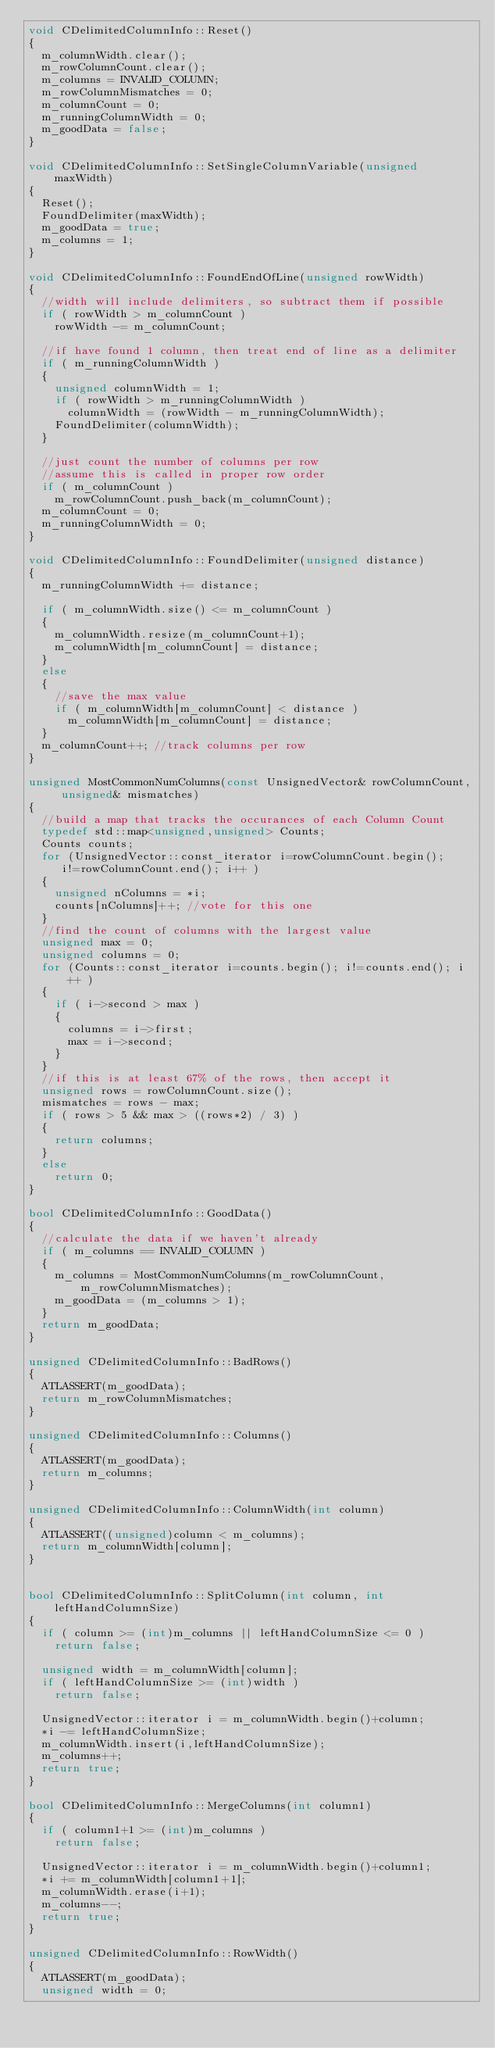Convert code to text. <code><loc_0><loc_0><loc_500><loc_500><_C++_>void CDelimitedColumnInfo::Reset()
{
	m_columnWidth.clear();
	m_rowColumnCount.clear();
	m_columns = INVALID_COLUMN;
	m_rowColumnMismatches = 0;
	m_columnCount = 0;
	m_runningColumnWidth = 0;
	m_goodData = false;
}

void CDelimitedColumnInfo::SetSingleColumnVariable(unsigned maxWidth)
{
	Reset();
	FoundDelimiter(maxWidth);
	m_goodData = true;
	m_columns = 1;
}

void CDelimitedColumnInfo::FoundEndOfLine(unsigned rowWidth)
{
	//width will include delimiters, so subtract them if possible
	if ( rowWidth > m_columnCount )
		rowWidth -= m_columnCount;

	//if have found 1 column, then treat end of line as a delimiter
	if ( m_runningColumnWidth )
	{
		unsigned columnWidth = 1;
		if ( rowWidth > m_runningColumnWidth )
			columnWidth = (rowWidth - m_runningColumnWidth);
		FoundDelimiter(columnWidth);
	}

	//just count the number of columns per row
	//assume this is called in proper row order
	if ( m_columnCount )
		m_rowColumnCount.push_back(m_columnCount);
	m_columnCount = 0;
	m_runningColumnWidth = 0;
}

void CDelimitedColumnInfo::FoundDelimiter(unsigned distance)
{
	m_runningColumnWidth += distance;

	if ( m_columnWidth.size() <= m_columnCount )
	{
		m_columnWidth.resize(m_columnCount+1);
		m_columnWidth[m_columnCount] = distance;
	}
	else
	{
		//save the max value
		if ( m_columnWidth[m_columnCount] < distance )
			m_columnWidth[m_columnCount] = distance;
	}
	m_columnCount++; //track columns per row
}

unsigned MostCommonNumColumns(const UnsignedVector& rowColumnCount, unsigned& mismatches)
{
	//build a map that tracks the occurances of each Column Count
	typedef std::map<unsigned,unsigned> Counts;
	Counts counts;
	for (UnsignedVector::const_iterator i=rowColumnCount.begin();
		 i!=rowColumnCount.end(); i++ )
	{
		unsigned nColumns = *i;
		counts[nColumns]++; //vote for this one
	}
	//find the count of columns with the largest value
	unsigned max = 0;
	unsigned columns = 0;
	for (Counts::const_iterator i=counts.begin(); i!=counts.end(); i++ )
	{
		if ( i->second > max )
		{
			columns = i->first;
			max = i->second;
		}
	}
	//if this is at least 67% of the rows, then accept it
	unsigned rows = rowColumnCount.size();
	mismatches = rows - max;
	if ( rows > 5 && max > ((rows*2) / 3) )
	{
		return columns;
	}
	else
		return 0;
}

bool CDelimitedColumnInfo::GoodData()
{
	//calculate the data if we haven't already
	if ( m_columns == INVALID_COLUMN )
	{
		m_columns = MostCommonNumColumns(m_rowColumnCount,m_rowColumnMismatches);
		m_goodData = (m_columns > 1);
	}
	return m_goodData;
}

unsigned CDelimitedColumnInfo::BadRows()
{
	ATLASSERT(m_goodData);
	return m_rowColumnMismatches;
}

unsigned CDelimitedColumnInfo::Columns()
{
	ATLASSERT(m_goodData);
	return m_columns;
}

unsigned CDelimitedColumnInfo::ColumnWidth(int column)
{
	ATLASSERT((unsigned)column < m_columns);
	return m_columnWidth[column];
}


bool CDelimitedColumnInfo::SplitColumn(int column, int leftHandColumnSize)
{
	if ( column >= (int)m_columns || leftHandColumnSize <= 0 )
		return false;

	unsigned width = m_columnWidth[column];
	if ( leftHandColumnSize >= (int)width )
		return false;

	UnsignedVector::iterator i = m_columnWidth.begin()+column;
	*i -= leftHandColumnSize;
	m_columnWidth.insert(i,leftHandColumnSize);
	m_columns++;
	return true;
}

bool CDelimitedColumnInfo::MergeColumns(int column1)
{
	if ( column1+1 >= (int)m_columns )
		return false;

	UnsignedVector::iterator i = m_columnWidth.begin()+column1;
	*i += m_columnWidth[column1+1];
	m_columnWidth.erase(i+1);
	m_columns--;
	return true;
}

unsigned CDelimitedColumnInfo::RowWidth()
{
	ATLASSERT(m_goodData);
	unsigned width = 0;</code> 